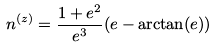Convert formula to latex. <formula><loc_0><loc_0><loc_500><loc_500>n ^ { ( z ) } = \frac { 1 + e ^ { 2 } } { e ^ { 3 } } ( e - \arctan ( e ) )</formula> 